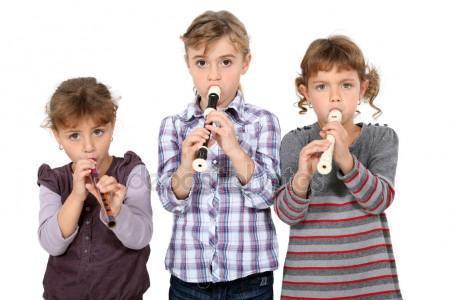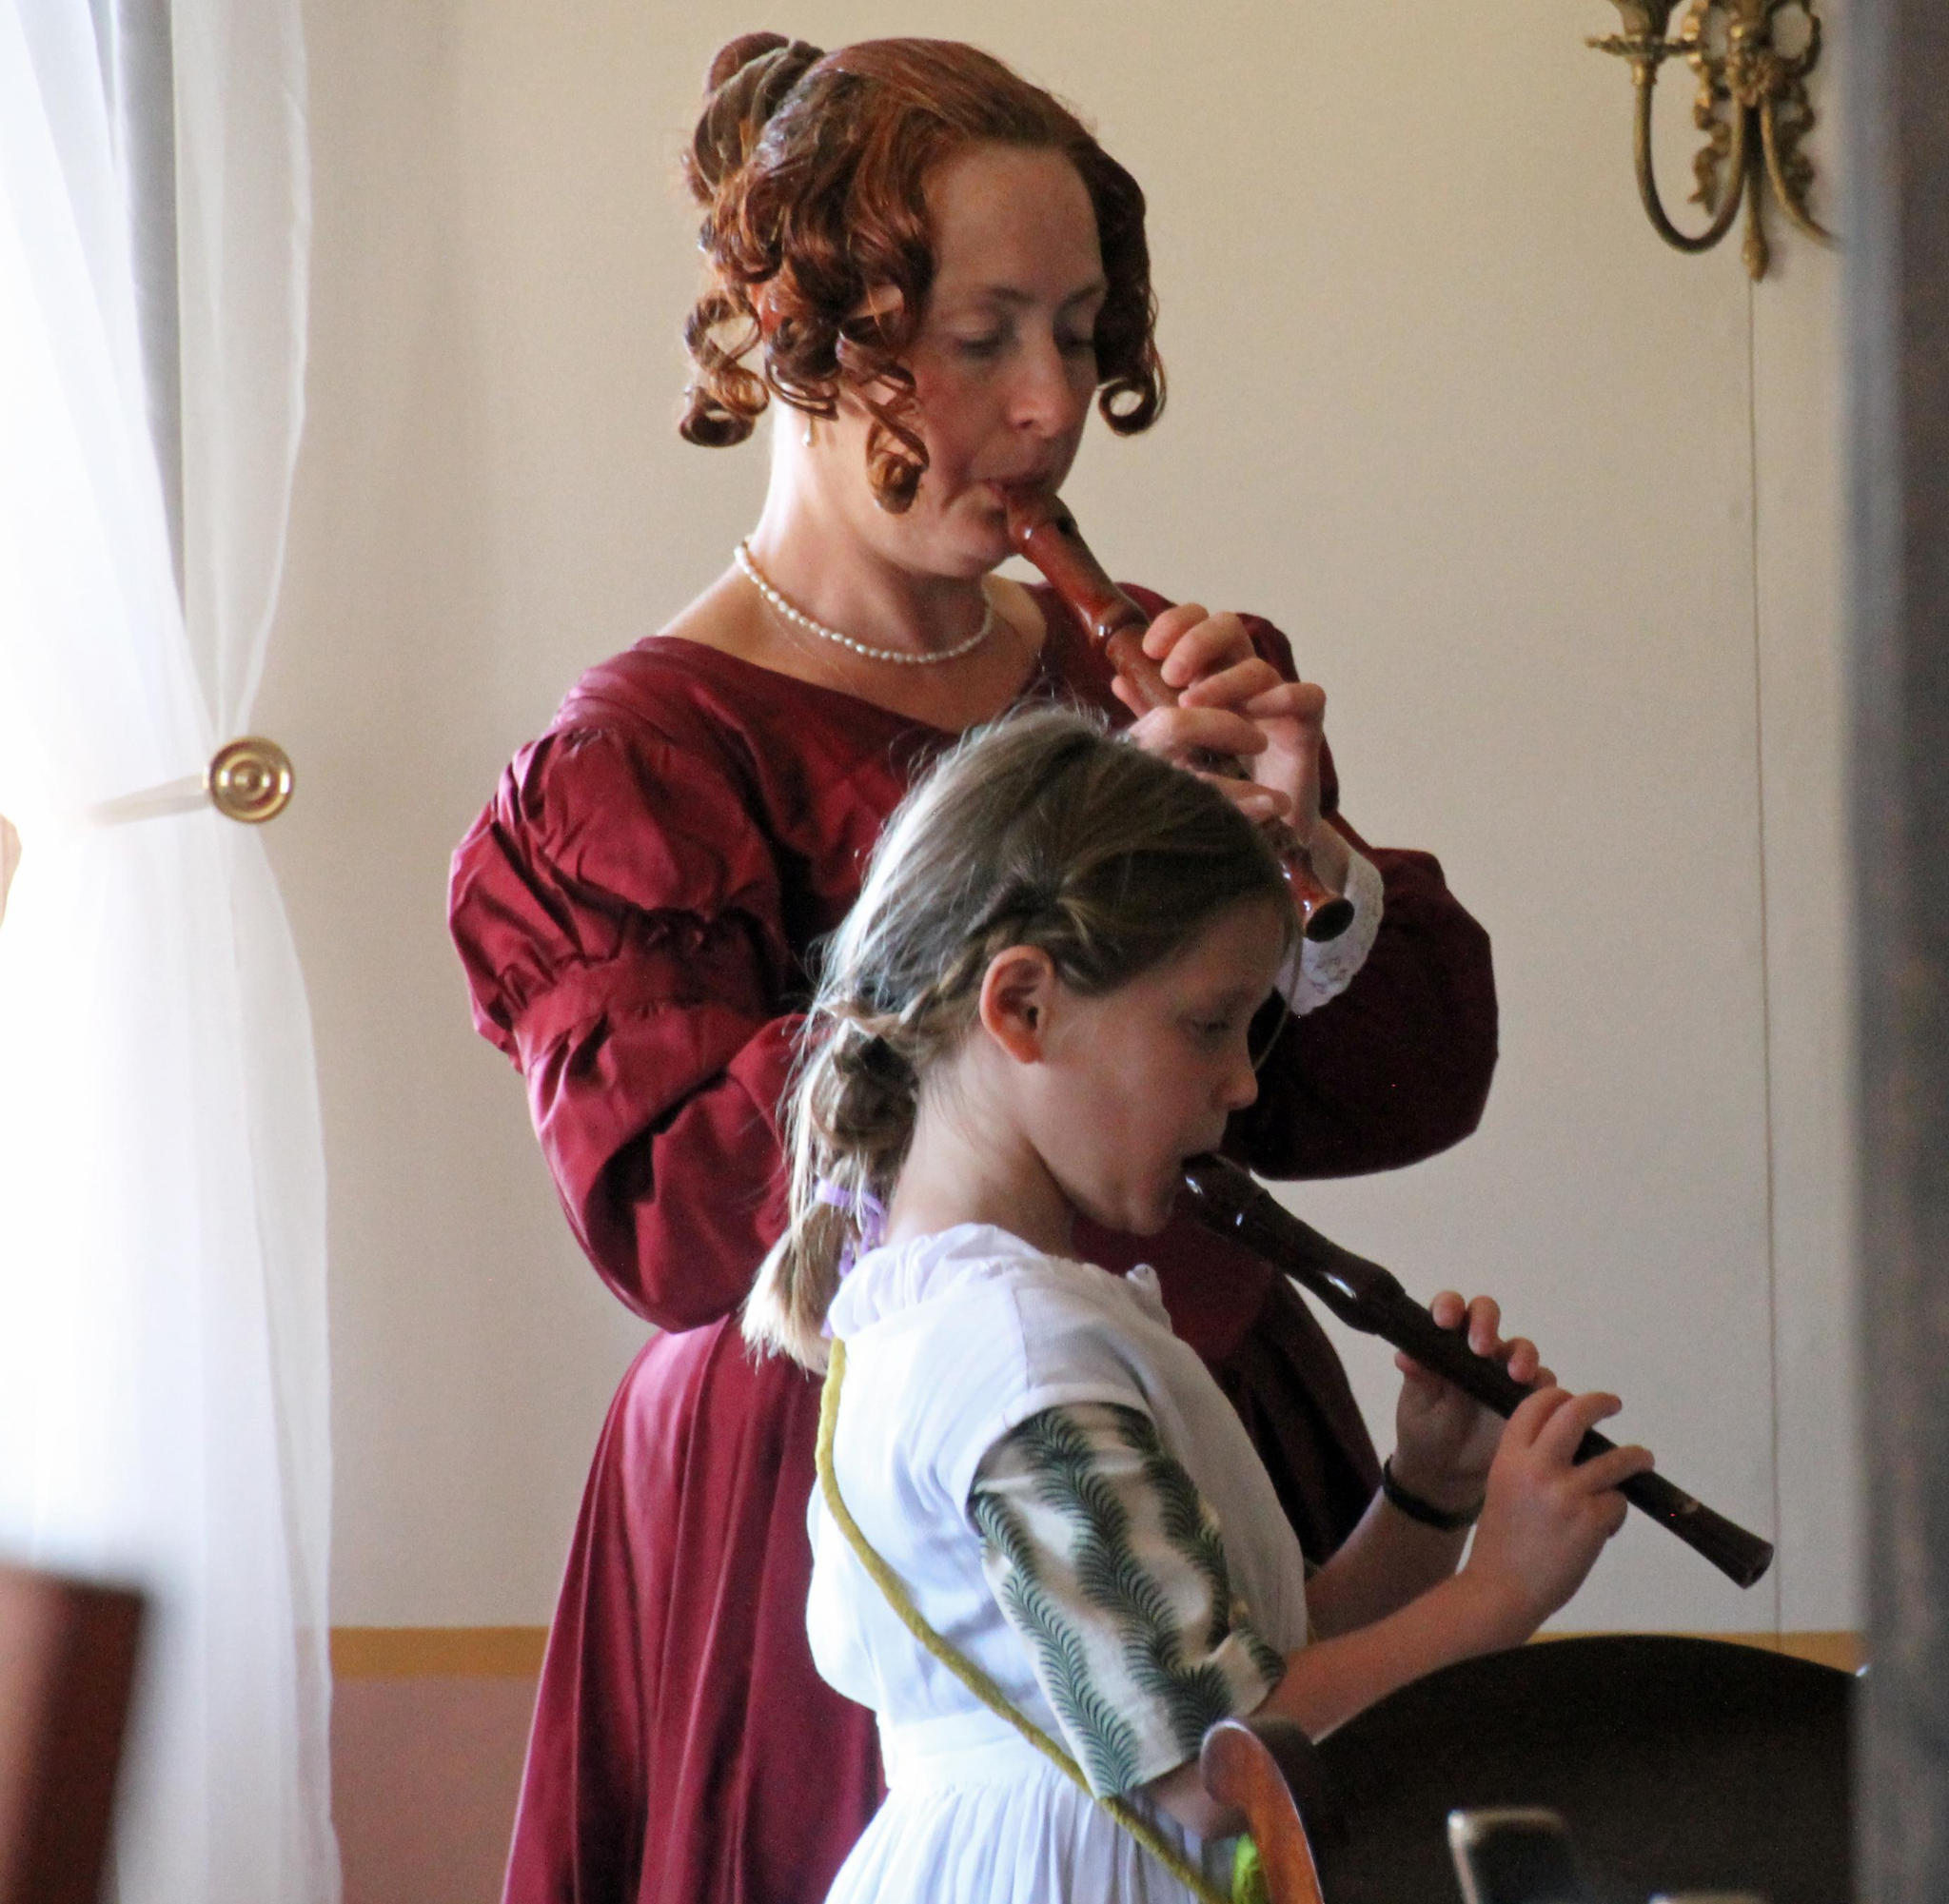The first image is the image on the left, the second image is the image on the right. Considering the images on both sides, is "At least one of the people is wearing a green shirt." valid? Answer yes or no. No. The first image is the image on the left, the second image is the image on the right. Examine the images to the left and right. Is the description "One image shows one female playing a straight wind instrument, and the other image shows one male in green sleeves playing a wooden wind instrument." accurate? Answer yes or no. No. 